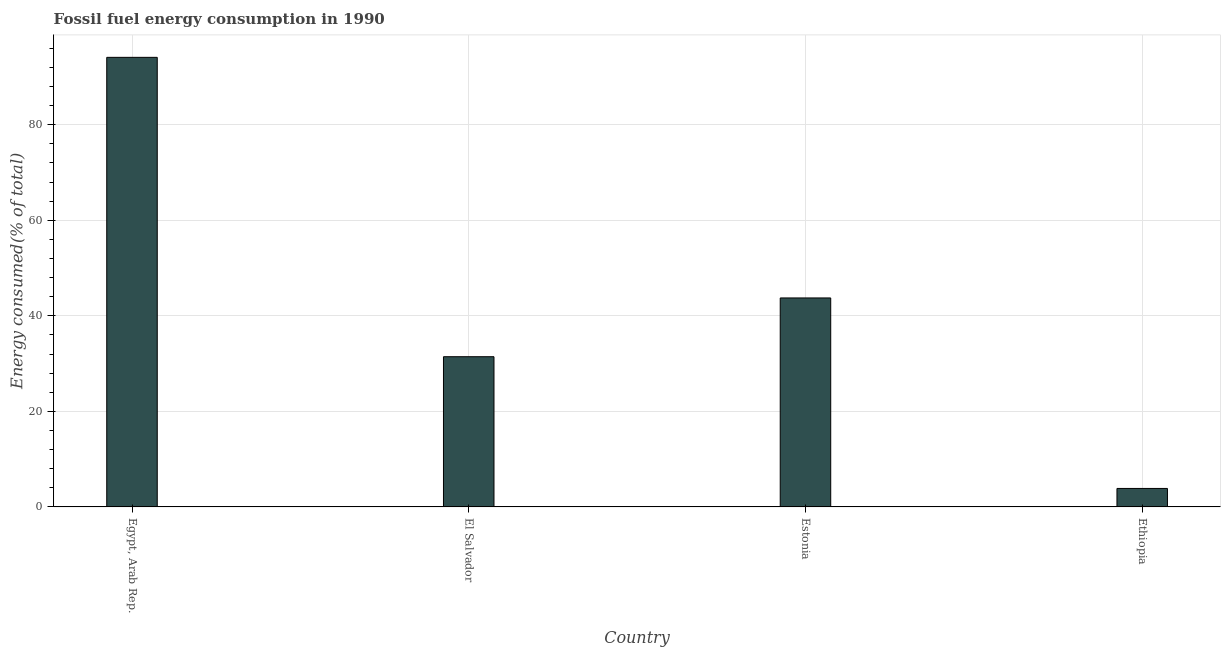Does the graph contain any zero values?
Offer a terse response. No. Does the graph contain grids?
Offer a very short reply. Yes. What is the title of the graph?
Make the answer very short. Fossil fuel energy consumption in 1990. What is the label or title of the X-axis?
Provide a short and direct response. Country. What is the label or title of the Y-axis?
Provide a short and direct response. Energy consumed(% of total). What is the fossil fuel energy consumption in El Salvador?
Offer a very short reply. 31.44. Across all countries, what is the maximum fossil fuel energy consumption?
Provide a succinct answer. 94.09. Across all countries, what is the minimum fossil fuel energy consumption?
Give a very brief answer. 3.87. In which country was the fossil fuel energy consumption maximum?
Provide a short and direct response. Egypt, Arab Rep. In which country was the fossil fuel energy consumption minimum?
Your answer should be compact. Ethiopia. What is the sum of the fossil fuel energy consumption?
Your answer should be compact. 173.13. What is the difference between the fossil fuel energy consumption in Egypt, Arab Rep. and El Salvador?
Your response must be concise. 62.65. What is the average fossil fuel energy consumption per country?
Your response must be concise. 43.28. What is the median fossil fuel energy consumption?
Your answer should be compact. 37.59. What is the ratio of the fossil fuel energy consumption in El Salvador to that in Ethiopia?
Make the answer very short. 8.13. What is the difference between the highest and the second highest fossil fuel energy consumption?
Provide a short and direct response. 50.35. What is the difference between the highest and the lowest fossil fuel energy consumption?
Your response must be concise. 90.22. In how many countries, is the fossil fuel energy consumption greater than the average fossil fuel energy consumption taken over all countries?
Your answer should be very brief. 2. How many bars are there?
Provide a succinct answer. 4. What is the difference between two consecutive major ticks on the Y-axis?
Your answer should be compact. 20. Are the values on the major ticks of Y-axis written in scientific E-notation?
Ensure brevity in your answer.  No. What is the Energy consumed(% of total) of Egypt, Arab Rep.?
Make the answer very short. 94.09. What is the Energy consumed(% of total) of El Salvador?
Ensure brevity in your answer.  31.44. What is the Energy consumed(% of total) of Estonia?
Make the answer very short. 43.74. What is the Energy consumed(% of total) in Ethiopia?
Make the answer very short. 3.87. What is the difference between the Energy consumed(% of total) in Egypt, Arab Rep. and El Salvador?
Give a very brief answer. 62.65. What is the difference between the Energy consumed(% of total) in Egypt, Arab Rep. and Estonia?
Ensure brevity in your answer.  50.35. What is the difference between the Energy consumed(% of total) in Egypt, Arab Rep. and Ethiopia?
Offer a terse response. 90.22. What is the difference between the Energy consumed(% of total) in El Salvador and Estonia?
Provide a succinct answer. -12.3. What is the difference between the Energy consumed(% of total) in El Salvador and Ethiopia?
Your answer should be compact. 27.57. What is the difference between the Energy consumed(% of total) in Estonia and Ethiopia?
Ensure brevity in your answer.  39.87. What is the ratio of the Energy consumed(% of total) in Egypt, Arab Rep. to that in El Salvador?
Your answer should be very brief. 2.99. What is the ratio of the Energy consumed(% of total) in Egypt, Arab Rep. to that in Estonia?
Keep it short and to the point. 2.15. What is the ratio of the Energy consumed(% of total) in Egypt, Arab Rep. to that in Ethiopia?
Give a very brief answer. 24.32. What is the ratio of the Energy consumed(% of total) in El Salvador to that in Estonia?
Ensure brevity in your answer.  0.72. What is the ratio of the Energy consumed(% of total) in El Salvador to that in Ethiopia?
Give a very brief answer. 8.13. What is the ratio of the Energy consumed(% of total) in Estonia to that in Ethiopia?
Your answer should be very brief. 11.3. 